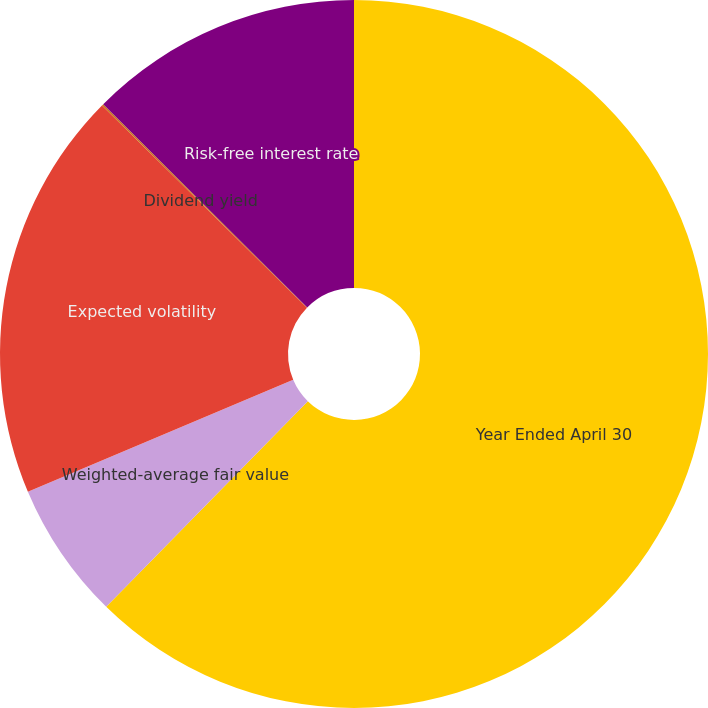Convert chart to OTSL. <chart><loc_0><loc_0><loc_500><loc_500><pie_chart><fcel>Year Ended April 30<fcel>Weighted-average fair value<fcel>Expected volatility<fcel>Dividend yield<fcel>Risk-free interest rate<nl><fcel>62.34%<fcel>6.3%<fcel>18.75%<fcel>0.08%<fcel>12.53%<nl></chart> 